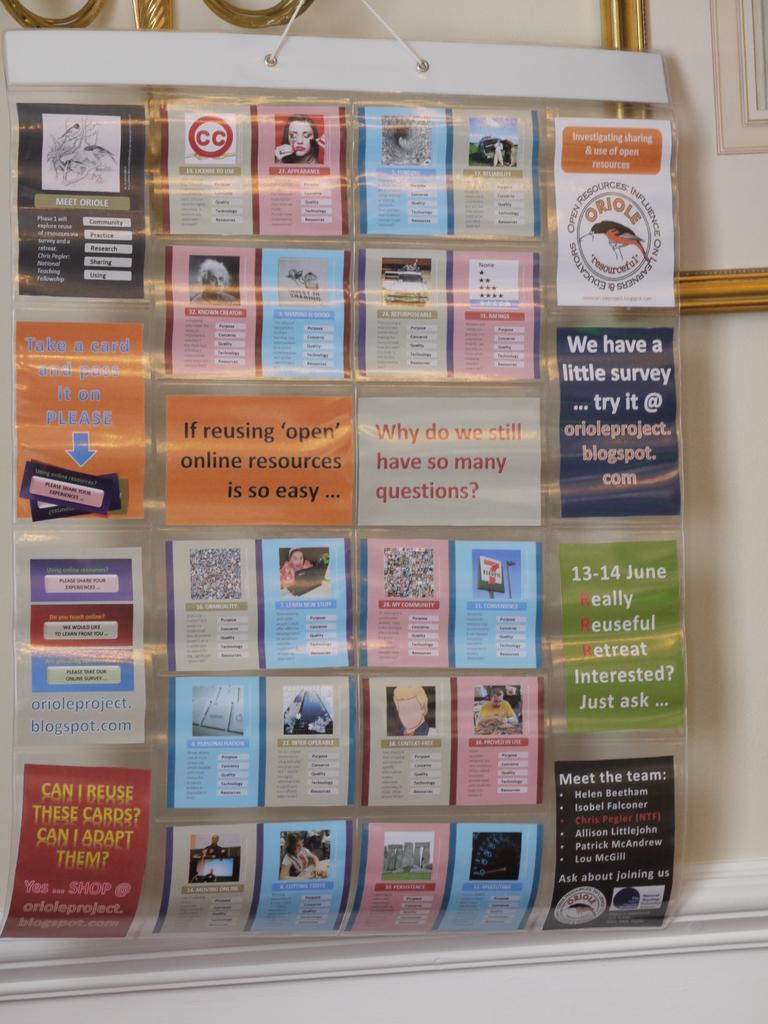<image>
Summarize the visual content of the image. Cards hanging on a wall including one that says "We have a little survey". 